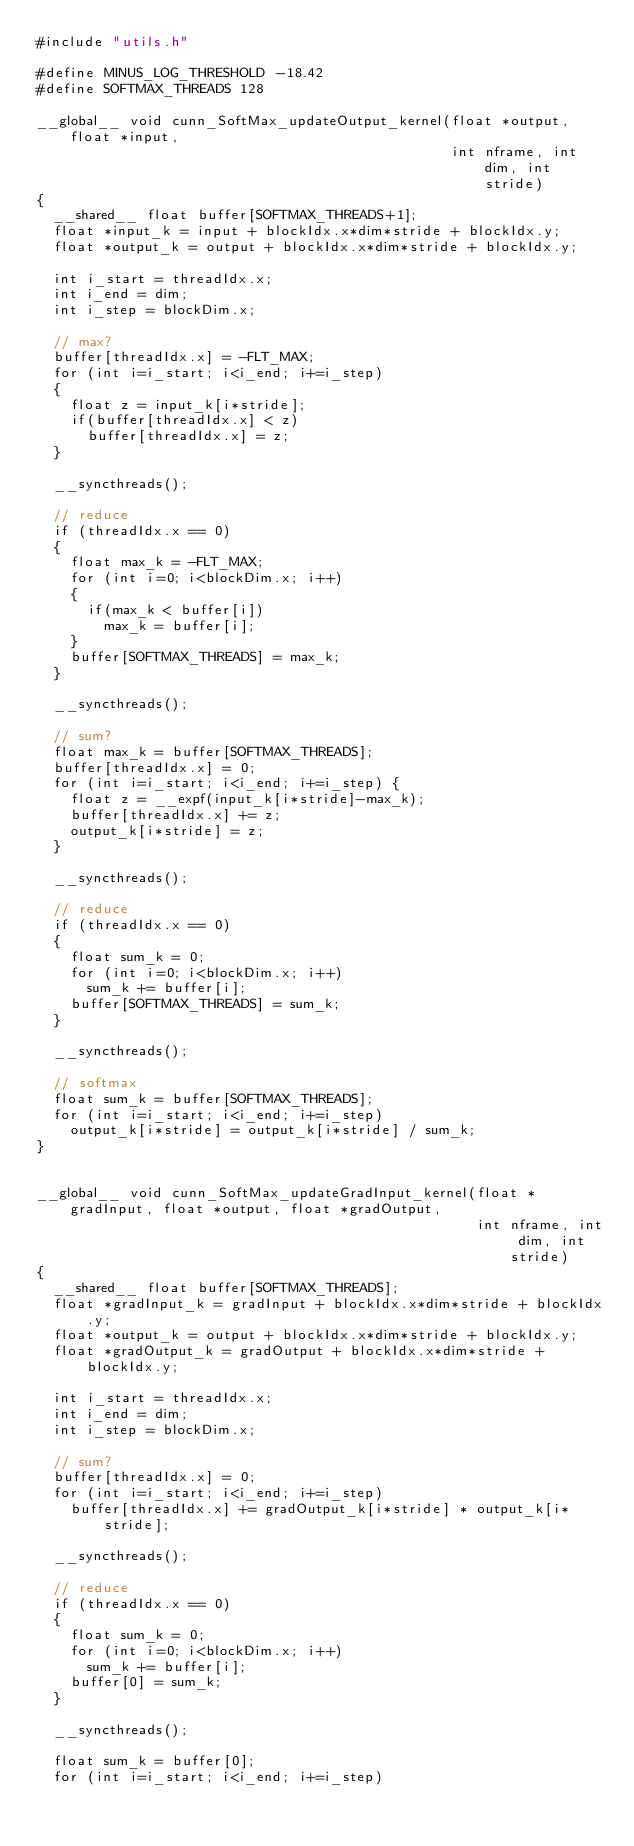<code> <loc_0><loc_0><loc_500><loc_500><_Cuda_>#include "utils.h"

#define MINUS_LOG_THRESHOLD -18.42
#define SOFTMAX_THREADS 128

__global__ void cunn_SoftMax_updateOutput_kernel(float *output, float *input,
                                                 int nframe, int dim, int stride)
{
  __shared__ float buffer[SOFTMAX_THREADS+1];
  float *input_k = input + blockIdx.x*dim*stride + blockIdx.y;
  float *output_k = output + blockIdx.x*dim*stride + blockIdx.y;

  int i_start = threadIdx.x;
  int i_end = dim;
  int i_step = blockDim.x;

  // max?
  buffer[threadIdx.x] = -FLT_MAX;
  for (int i=i_start; i<i_end; i+=i_step)
  {
    float z = input_k[i*stride];
    if(buffer[threadIdx.x] < z)
      buffer[threadIdx.x] = z;
  }

  __syncthreads();

  // reduce
  if (threadIdx.x == 0)
  {
    float max_k = -FLT_MAX;
    for (int i=0; i<blockDim.x; i++)
    {
      if(max_k < buffer[i])
        max_k = buffer[i];
    }
    buffer[SOFTMAX_THREADS] = max_k;
  }

  __syncthreads();

  // sum?
  float max_k = buffer[SOFTMAX_THREADS];
  buffer[threadIdx.x] = 0;
  for (int i=i_start; i<i_end; i+=i_step) {
    float z = __expf(input_k[i*stride]-max_k);
    buffer[threadIdx.x] += z;
    output_k[i*stride] = z;
  }

  __syncthreads();

  // reduce
  if (threadIdx.x == 0)
  {
    float sum_k = 0;
    for (int i=0; i<blockDim.x; i++)
      sum_k += buffer[i];
    buffer[SOFTMAX_THREADS] = sum_k;
  }

  __syncthreads();

  // softmax
  float sum_k = buffer[SOFTMAX_THREADS];
  for (int i=i_start; i<i_end; i+=i_step)
    output_k[i*stride] = output_k[i*stride] / sum_k;
}


__global__ void cunn_SoftMax_updateGradInput_kernel(float *gradInput, float *output, float *gradOutput,
                                                    int nframe, int dim, int stride)
{
  __shared__ float buffer[SOFTMAX_THREADS];
  float *gradInput_k = gradInput + blockIdx.x*dim*stride + blockIdx.y;
  float *output_k = output + blockIdx.x*dim*stride + blockIdx.y;
  float *gradOutput_k = gradOutput + blockIdx.x*dim*stride + blockIdx.y;

  int i_start = threadIdx.x;
  int i_end = dim;
  int i_step = blockDim.x;

  // sum?
  buffer[threadIdx.x] = 0;
  for (int i=i_start; i<i_end; i+=i_step)
    buffer[threadIdx.x] += gradOutput_k[i*stride] * output_k[i*stride];

  __syncthreads();

  // reduce
  if (threadIdx.x == 0)
  {
    float sum_k = 0;
    for (int i=0; i<blockDim.x; i++)
      sum_k += buffer[i];
    buffer[0] = sum_k;
  }

  __syncthreads();

  float sum_k = buffer[0];
  for (int i=i_start; i<i_end; i+=i_step)</code> 